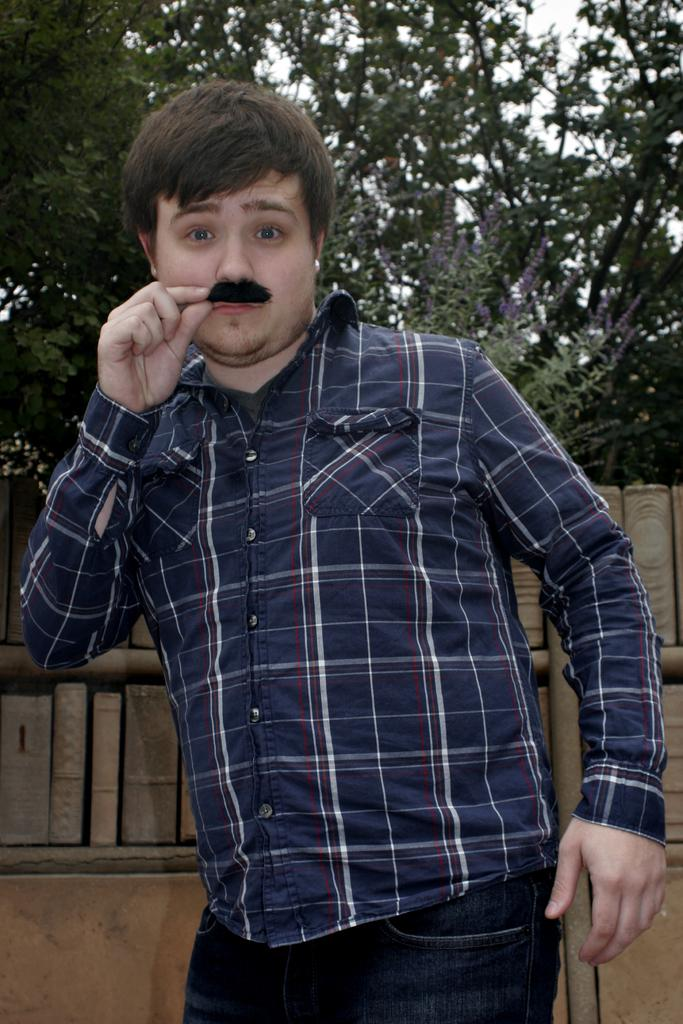What is the main subject of the image? There is a person standing in the image. What is the person wearing? The person is wearing a shirt. What can be seen in the background of the image? There are objects and trees in the background of the image. What else is visible in the background of the image? The sky is visible in the background of the image. What type of cave can be seen in the background of the image? There is no cave present in the image; it features a person standing in front of objects, trees, and the sky. 